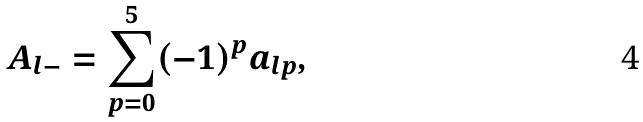<formula> <loc_0><loc_0><loc_500><loc_500>A _ { l - } = \sum _ { p = 0 } ^ { 5 } ( - 1 ) ^ { p } a _ { l p } ,</formula> 